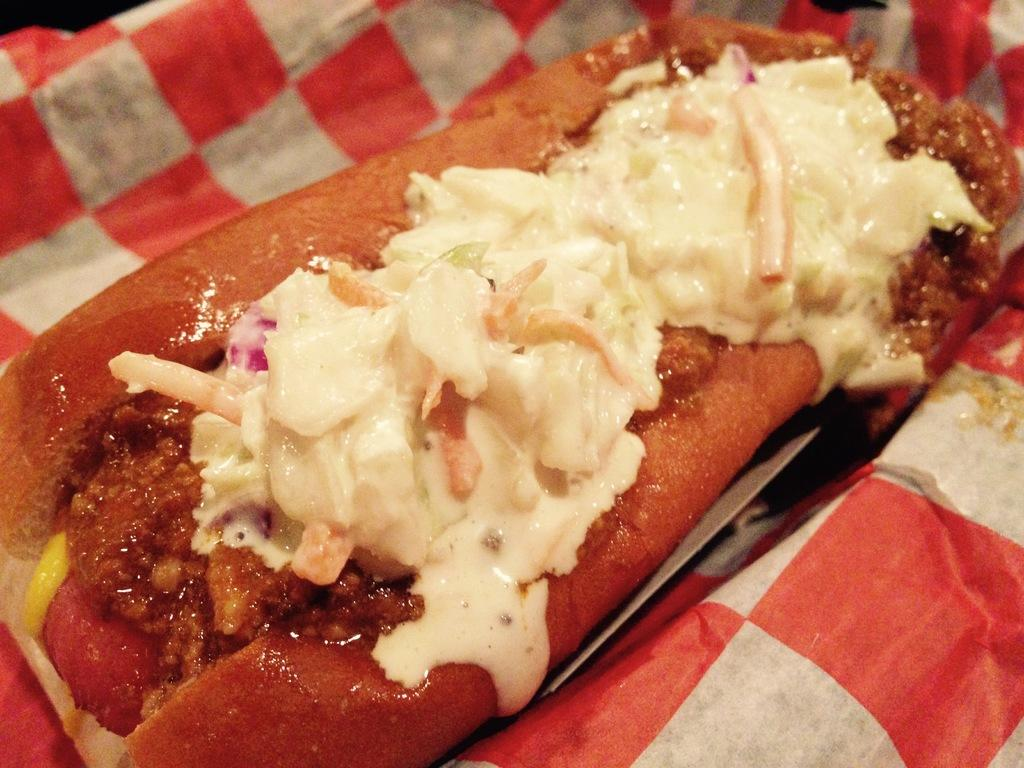What is present in the image? There are food items in the image. How are the food items arranged or presented? The food items are on a paper. What shape is the island in the image? There is no island present in the image; it features food items on a paper. How does the spark from the food items light up the room in the image? There is no spark or lighting effect mentioned in the image; it only shows food items on a paper. 